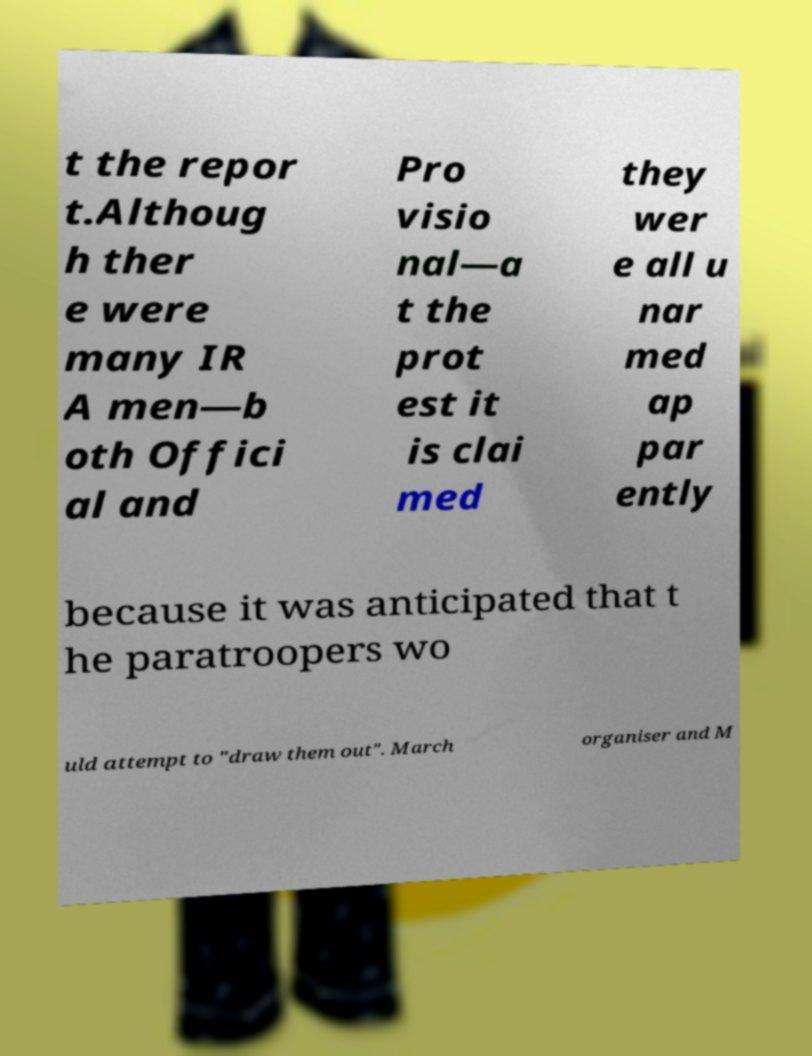Can you accurately transcribe the text from the provided image for me? t the repor t.Althoug h ther e were many IR A men—b oth Offici al and Pro visio nal—a t the prot est it is clai med they wer e all u nar med ap par ently because it was anticipated that t he paratroopers wo uld attempt to "draw them out". March organiser and M 